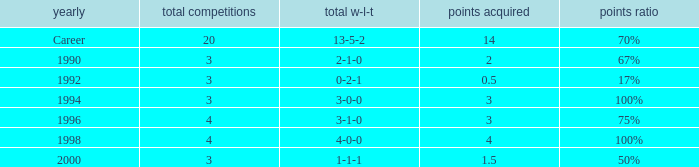Can you tell me the lowest Total natches that has the Points won of 3, and the Year of 1994? 3.0. Write the full table. {'header': ['yearly', 'total competitions', 'total w-l-t', 'points acquired', 'points ratio'], 'rows': [['Career', '20', '13-5-2', '14', '70%'], ['1990', '3', '2-1-0', '2', '67%'], ['1992', '3', '0-2-1', '0.5', '17%'], ['1994', '3', '3-0-0', '3', '100%'], ['1996', '4', '3-1-0', '3', '75%'], ['1998', '4', '4-0-0', '4', '100%'], ['2000', '3', '1-1-1', '1.5', '50%']]} 